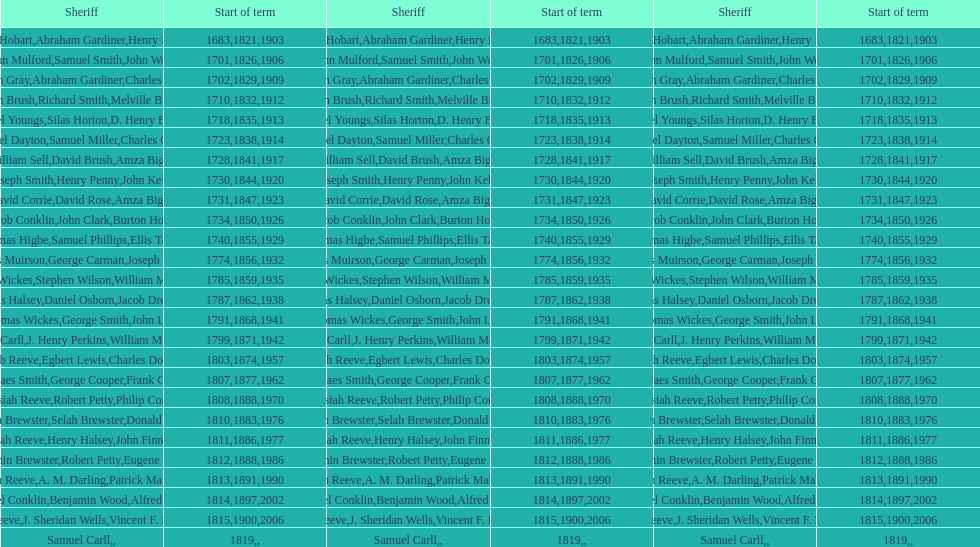What is the count of sheriffs with the surname smith? 5. 